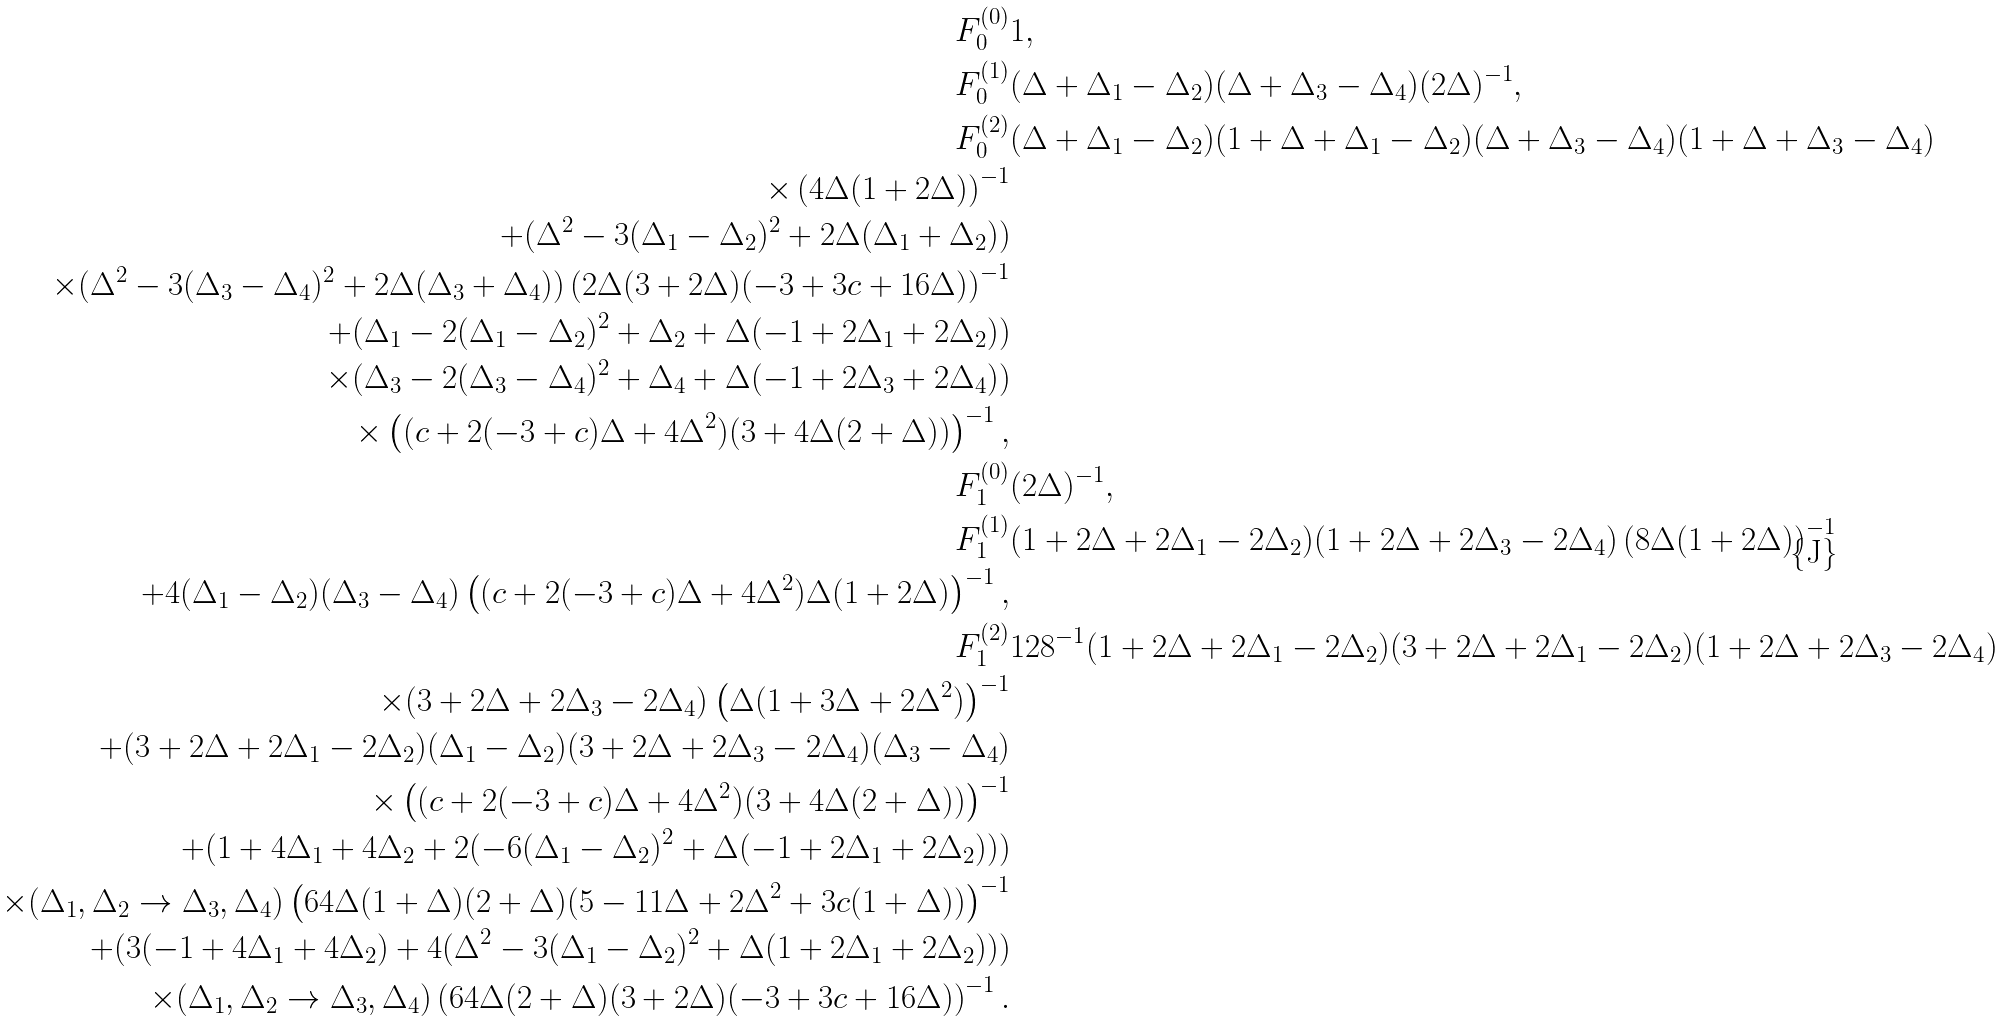Convert formula to latex. <formula><loc_0><loc_0><loc_500><loc_500>F _ { 0 } ^ { ( 0 ) } & 1 , \\ F _ { 0 } ^ { ( 1 ) } & ( \Delta + \Delta _ { 1 } - \Delta _ { 2 } ) ( \Delta + \Delta _ { 3 } - \Delta _ { 4 } ) ( 2 \Delta ) ^ { - 1 } , \\ F _ { 0 } ^ { ( 2 ) } & ( \Delta + \Delta _ { 1 } - \Delta _ { 2 } ) ( 1 + \Delta + \Delta _ { 1 } - \Delta _ { 2 } ) ( \Delta + \Delta _ { 3 } - \Delta _ { 4 } ) ( 1 + \Delta + \Delta _ { 3 } - \Delta _ { 4 } ) \\ \times \left ( 4 \Delta ( 1 + 2 \Delta ) \right ) ^ { - 1 } \\ + ( \Delta ^ { 2 } - 3 ( \Delta _ { 1 } - \Delta _ { 2 } ) ^ { 2 } + 2 \Delta ( \Delta _ { 1 } + \Delta _ { 2 } ) ) \\ \times ( \Delta ^ { 2 } - 3 ( \Delta _ { 3 } - \Delta _ { 4 } ) ^ { 2 } + 2 \Delta ( \Delta _ { 3 } + \Delta _ { 4 } ) ) \left ( 2 \Delta ( 3 + 2 \Delta ) ( - 3 + 3 c + 1 6 \Delta ) \right ) ^ { - 1 } \\ + ( \Delta _ { 1 } - 2 ( \Delta _ { 1 } - \Delta _ { 2 } ) ^ { 2 } + \Delta _ { 2 } + \Delta ( - 1 + 2 \Delta _ { 1 } + 2 \Delta _ { 2 } ) ) \\ \times ( \Delta _ { 3 } - 2 ( \Delta _ { 3 } - \Delta _ { 4 } ) ^ { 2 } + \Delta _ { 4 } + \Delta ( - 1 + 2 \Delta _ { 3 } + 2 \Delta _ { 4 } ) ) \\ \times \left ( ( c + 2 ( - 3 + c ) \Delta + 4 \Delta ^ { 2 } ) ( 3 + 4 \Delta ( 2 + \Delta ) ) \right ) ^ { - 1 } , \\ F _ { 1 } ^ { ( 0 ) } & ( 2 \Delta ) ^ { - 1 } , \\ F _ { 1 } ^ { ( 1 ) } & ( 1 + 2 \Delta + 2 \Delta _ { 1 } - 2 \Delta _ { 2 } ) ( 1 + 2 \Delta + 2 \Delta _ { 3 } - 2 \Delta _ { 4 } ) \left ( 8 \Delta ( 1 + 2 \Delta ) \right ) ^ { - 1 } \\ + 4 ( \Delta _ { 1 } - \Delta _ { 2 } ) ( \Delta _ { 3 } - \Delta _ { 4 } ) \left ( ( c + 2 ( - 3 + c ) \Delta + 4 \Delta ^ { 2 } ) \Delta ( 1 + 2 \Delta ) \right ) ^ { - 1 } , \\ F _ { 1 } ^ { ( 2 ) } & 1 2 8 ^ { - 1 } ( 1 + 2 \Delta + 2 \Delta _ { 1 } - 2 \Delta _ { 2 } ) ( 3 + 2 \Delta + 2 \Delta _ { 1 } - 2 \Delta _ { 2 } ) ( 1 + 2 \Delta + 2 \Delta _ { 3 } - 2 \Delta _ { 4 } ) \\ \times ( 3 + 2 \Delta + 2 \Delta _ { 3 } - 2 \Delta _ { 4 } ) \left ( \Delta ( 1 + 3 \Delta + 2 \Delta ^ { 2 } ) \right ) ^ { - 1 } \\ + ( 3 + 2 \Delta + 2 \Delta _ { 1 } - 2 \Delta _ { 2 } ) ( \Delta _ { 1 } - \Delta _ { 2 } ) ( 3 + 2 \Delta + 2 \Delta _ { 3 } - 2 \Delta _ { 4 } ) ( \Delta _ { 3 } - \Delta _ { 4 } ) \\ \times \left ( ( c + 2 ( - 3 + c ) \Delta + 4 \Delta ^ { 2 } ) ( 3 + 4 \Delta ( 2 + \Delta ) ) \right ) ^ { - 1 } \\ + ( 1 + 4 \Delta _ { 1 } + 4 \Delta _ { 2 } + 2 ( - 6 ( \Delta _ { 1 } - \Delta _ { 2 } ) ^ { 2 } + \Delta ( - 1 + 2 \Delta _ { 1 } + 2 \Delta _ { 2 } ) ) ) \\ \times ( \Delta _ { 1 } , \Delta _ { 2 } \to \Delta _ { 3 } , \Delta _ { 4 } ) \left ( 6 4 \Delta ( 1 + \Delta ) ( 2 + \Delta ) ( 5 - 1 1 \Delta + 2 \Delta ^ { 2 } + 3 c ( 1 + \Delta ) ) \right ) ^ { - 1 } \\ + ( 3 ( - 1 + 4 \Delta _ { 1 } + 4 \Delta _ { 2 } ) + 4 ( \Delta ^ { 2 } - 3 ( \Delta _ { 1 } - \Delta _ { 2 } ) ^ { 2 } + \Delta ( 1 + 2 \Delta _ { 1 } + 2 \Delta _ { 2 } ) ) ) \\ \times ( \Delta _ { 1 } , \Delta _ { 2 } \to \Delta _ { 3 } , \Delta _ { 4 } ) \left ( 6 4 \Delta ( 2 + \Delta ) ( 3 + 2 \Delta ) ( - 3 + 3 c + 1 6 \Delta ) \right ) ^ { - 1 } .</formula> 